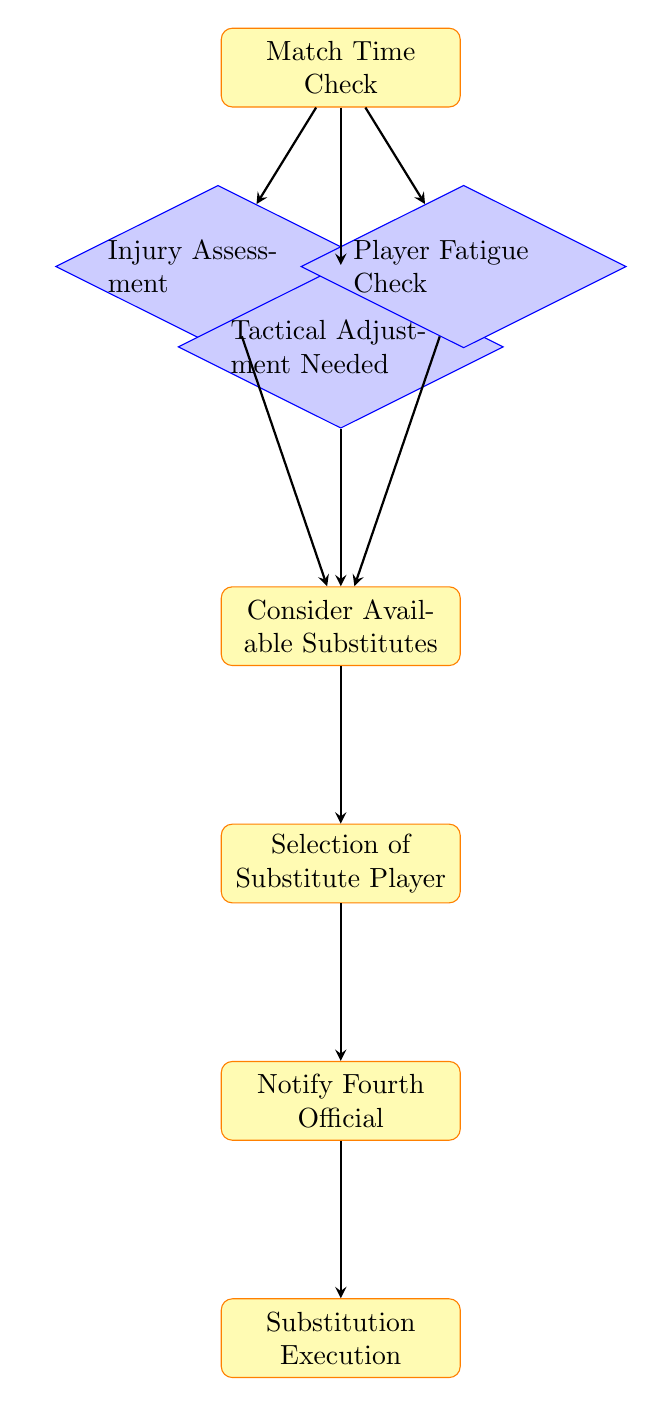What is the first step in the substitution process? The first step in the substitution process is the "Match Time Check," which is indicated as the initial node in the flowchart.
Answer: Match Time Check How many decision nodes are in the diagram? There are four decision nodes in the diagram, which are "Injury Assessment," "Tactical Adjustment Needed," "Player Fatigue Check," and the initiating node leads to them.
Answer: Four Which node leads to "Consider Available Substitutes"? "Consider Available Substitutes" is reached from three nodes: "Injury Assessment," "Tactical Adjustment Needed," and "Player Fatigue Check." This means any of these preceding decisions can lead to considering substitutes.
Answer: Injury Assessment, Tactical Adjustment Needed, Player Fatigue Check What is the last step in the process? The last step in the process is "Substitution Execution," which is the concluding node of the flowchart after notifying the fourth official.
Answer: Substitution Execution Which decision node directly leads to the selection of a substitute player? The node "Consider Available Substitutes" directly leads to the selection of a substitute player, indicating the players need to be evaluated before selection.
Answer: Consider Available Substitutes What happens after notifying the fourth official? After notifying the fourth official, the next step is "Substitution Execution," which indicates the action of substituting a player is taken next.
Answer: Substitution Execution Can a tactical adjustment lead directly to the player selection process? No, a tactical adjustment cannot lead directly to player selection; it first leads to considering available substitutes before selecting a player.
Answer: No 